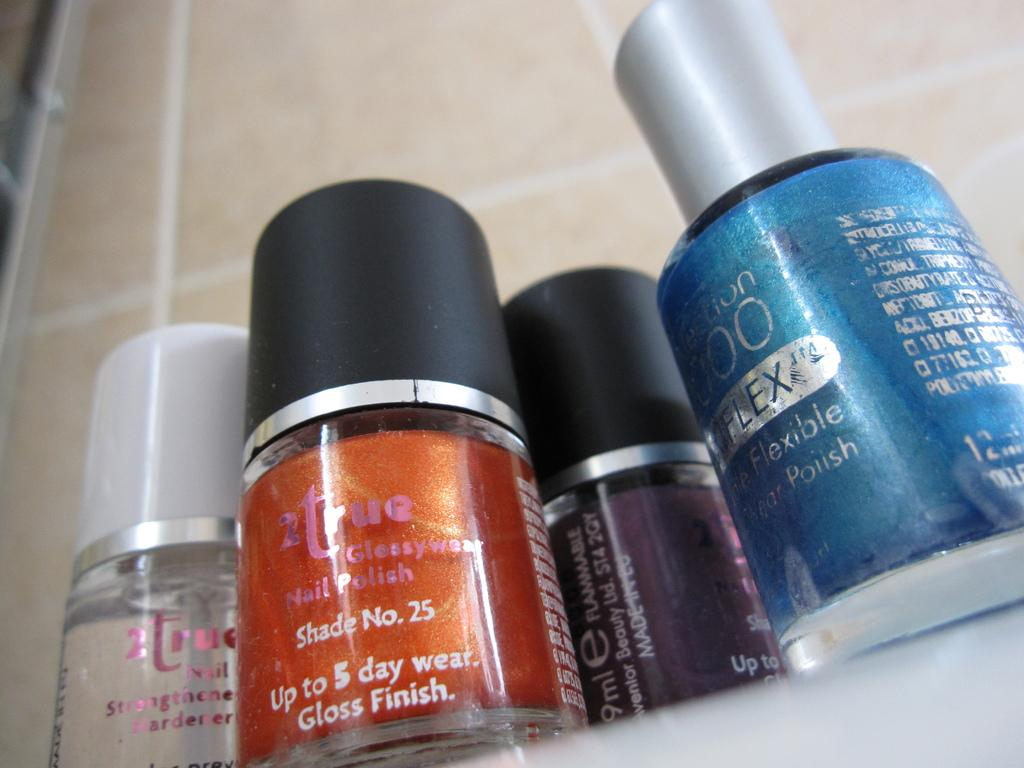Provide a one-sentence caption for the provided image. Bottles of nail polish with one that says Shade number 25. 